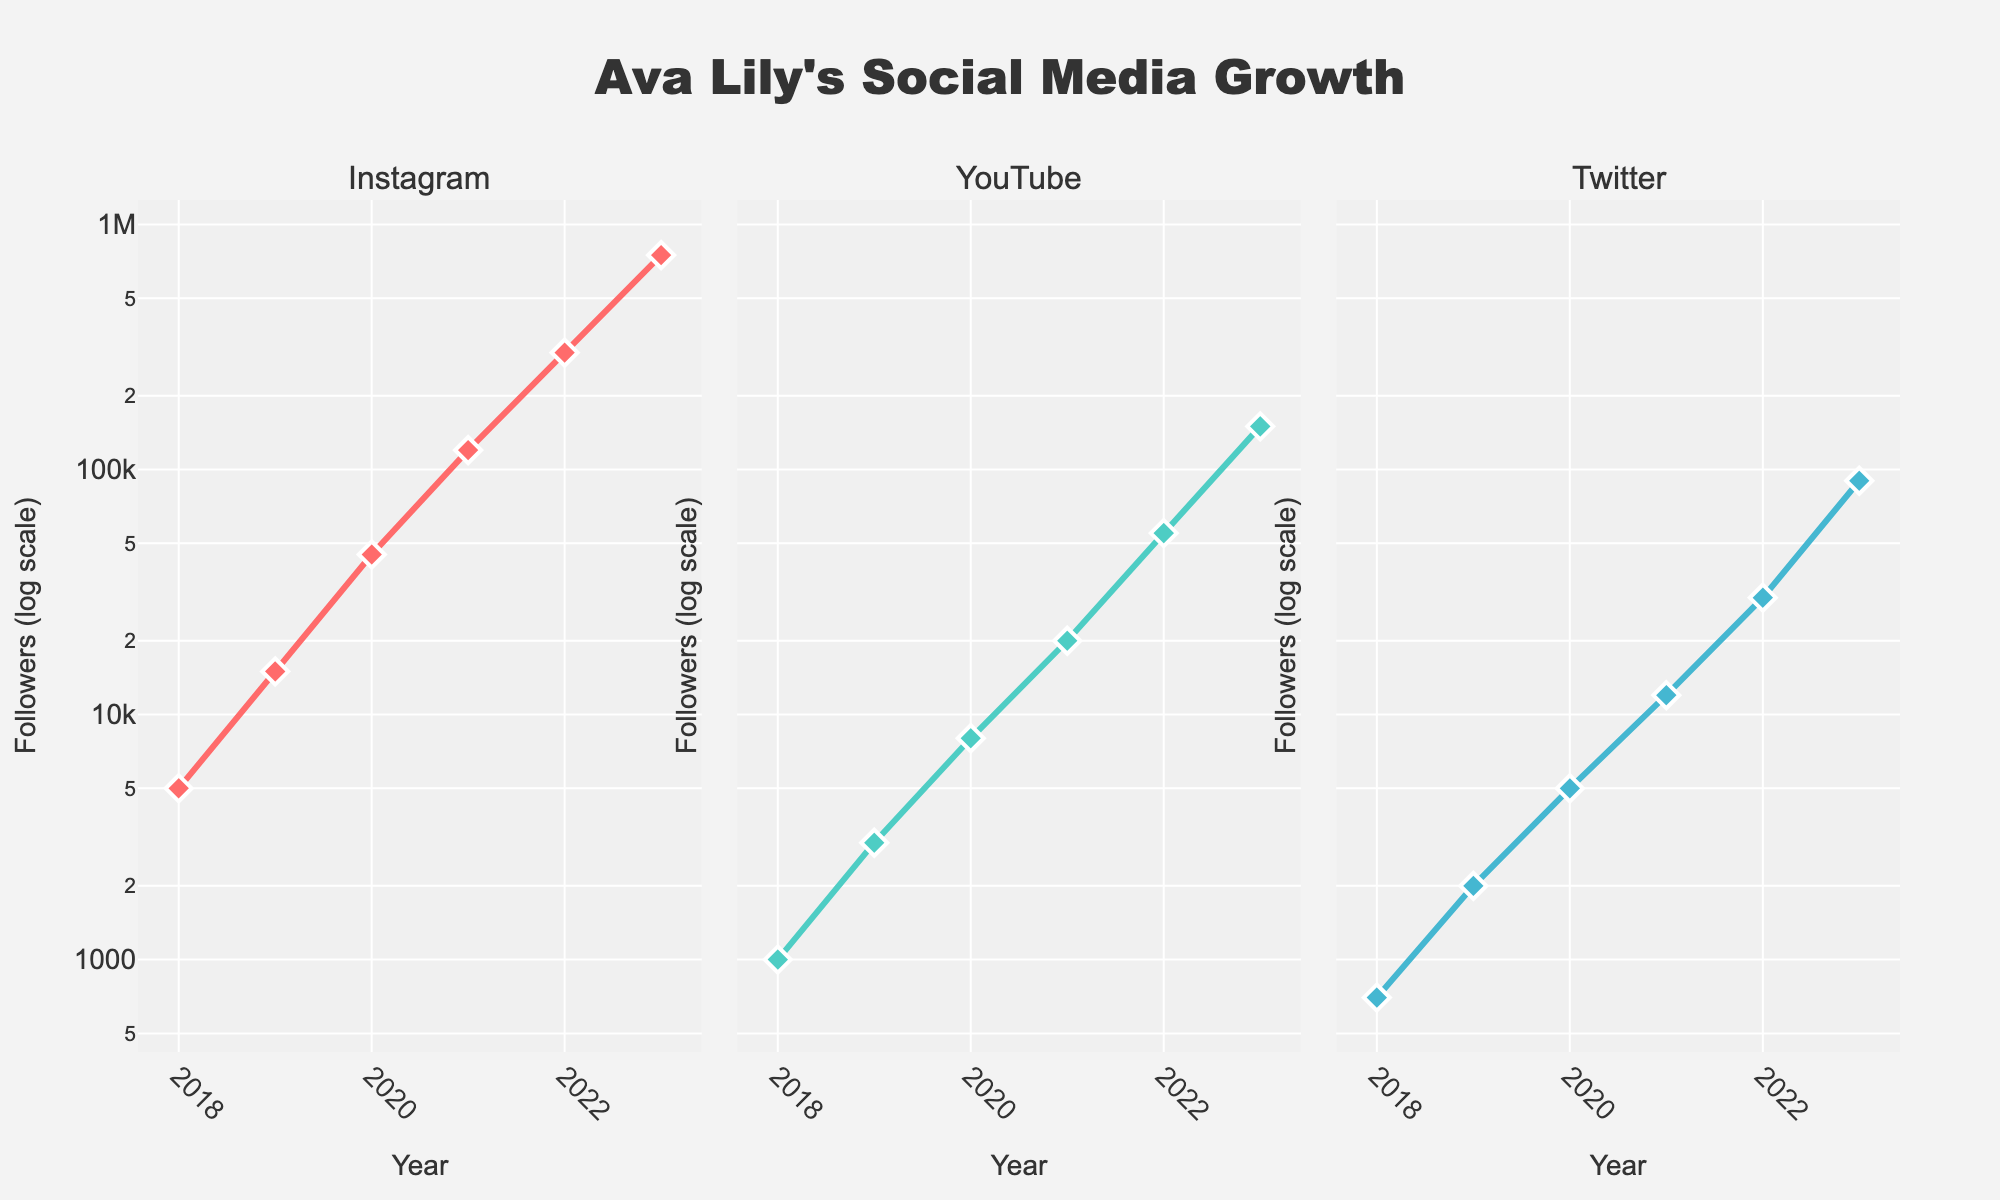What is the title of the figure? The figure's title is provided at the top center of the plot. Observing the large, bold text that stands out identifies the title.
Answer: Ava Lily's Social Media Growth How many platforms are compared in the figure? The figure has three subplots, one for each platform. The subplot titles above each plot indicate the different platforms being compared.
Answer: 3 Which platform had the highest number of followers in 2023? To determine this, review the y-axis value at 2023 for each subplot. The Instagram subplot shows the highest y-value at 750,000 followers.
Answer: Instagram How has the number of YouTube followers changed from 2020 to 2023? Identify the y-values for YouTube at 2020 and 2023. In 2020, YouTube had 8,000 followers, and in 2023, it had 150,000 followers. The change is 150,000 - 8,000.
Answer: Increased by 142,000 Which year experienced the most significant growth in Instagram followers? Compare the slope of the line in the Instagram subplot between consecutive years. The line from 2019 to 2020 shows the most significant growth, from 15,000 to 45,000 followers.
Answer: 2019 to 2020 Across platforms, which year had the smallest discrepancy in the number of followers between the highest and lowest platforms? Calculate the differences for each year: (2018: 5000 - 700 = 4300), (2019: 15000 - 2000 = 13000), (2020: 45000 - 5000 = 40000), (2021: 120000 - 12000 = 108000), (2022: 300000 - 30000 = 270000), (2023: 750000 - 90000 = 660000). 2018 has the smallest discrepancy.
Answer: 2018 Considering the overall trend from 2018 to 2023, which platform shows the most consistent growth in followers? Evaluate the smoothness and consistency of the line in each subplot. The Instagram subplot shows a consistently increasing trend without sharp changes.
Answer: Instagram What does the log scale on the y-axis signify for interpreting follower growth? The log scale means that equal vertical distances represent multiplicative changes, making it easier to compare growth rates across vastly different magnitudes.
Answer: Easier comparison of growth rates In which year did Twitter have the least number of followers, and how many were there? Inspect the Twitter subplot for the lowest point on the y-axis. In 2018, Twitter had the fewest followers at 700.
Answer: 2018, 700 followers Among the platforms, which had the lowest follower count growth rate from 2018 to 2023? Compare the slopes of the lines across all platforms. Twitter's line has the smallest overall increase, going from 700 in 2018 to 90,000 in 2023.
Answer: Twitter 